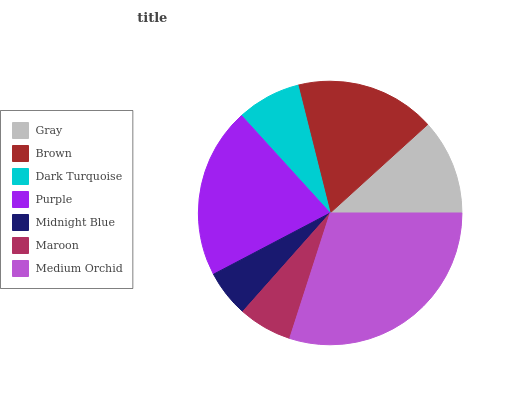Is Midnight Blue the minimum?
Answer yes or no. Yes. Is Medium Orchid the maximum?
Answer yes or no. Yes. Is Brown the minimum?
Answer yes or no. No. Is Brown the maximum?
Answer yes or no. No. Is Brown greater than Gray?
Answer yes or no. Yes. Is Gray less than Brown?
Answer yes or no. Yes. Is Gray greater than Brown?
Answer yes or no. No. Is Brown less than Gray?
Answer yes or no. No. Is Gray the high median?
Answer yes or no. Yes. Is Gray the low median?
Answer yes or no. Yes. Is Dark Turquoise the high median?
Answer yes or no. No. Is Maroon the low median?
Answer yes or no. No. 